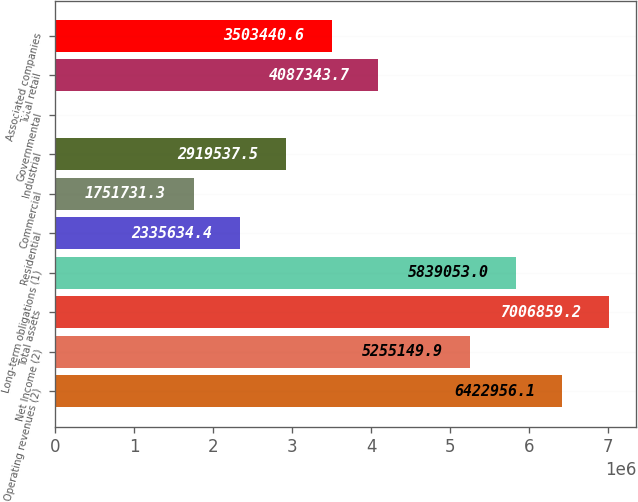Convert chart to OTSL. <chart><loc_0><loc_0><loc_500><loc_500><bar_chart><fcel>Operating revenues (2)<fcel>Net Income (2)<fcel>Total assets<fcel>Long-term obligations (1)<fcel>Residential<fcel>Commercial<fcel>Industrial<fcel>Governmental<fcel>Total retail<fcel>Associated companies<nl><fcel>6.42296e+06<fcel>5.25515e+06<fcel>7.00686e+06<fcel>5.83905e+06<fcel>2.33563e+06<fcel>1.75173e+06<fcel>2.91954e+06<fcel>22<fcel>4.08734e+06<fcel>3.50344e+06<nl></chart> 